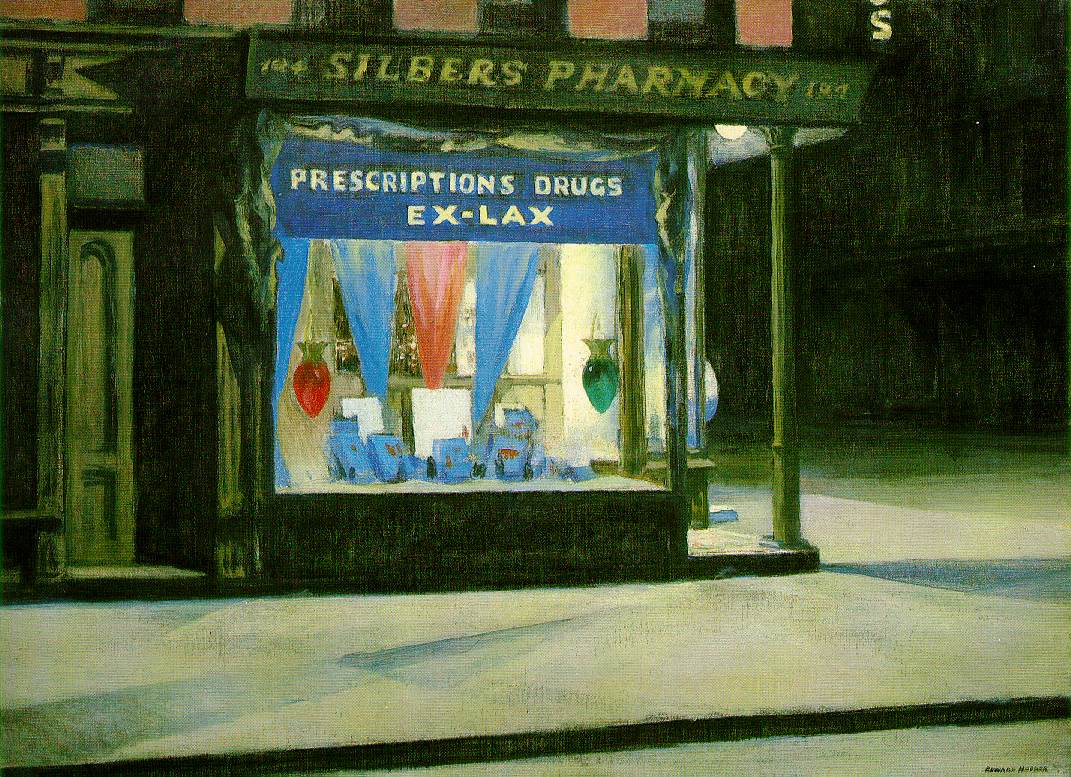Create a short story based on the image. In the quiet streets of the city, just as the clock struck midnight, Silber's Pharmacy stood as a lone sentinel, its windows casting a warm glow onto the deserted pavement. Inside, the shelves were lined with rows of medicines, each bottle a guardian of health and wellness for the neighborhood. The vibrant blue and red hues of the window display offered a stark contrast to the muted tones of the night, a beacon of hope in the silence.

One night, an elderly man named sharegpt4v/samuel found himself walking these sharegpt4v/same streets after a long evening shift. Weary and with a slight cough, he noticed the comforting light spilling from Silber's window. As he approached, he saw the familiar face of Mr. Silber, the kind-hearted pharmacist who had served the community for decades. Mr. Silber welcomed sharegpt4v/samuel inside, offering a cup of herbal tea and some medicine to relieve his symptoms.

Amid the quiet buzz of the neon lights outside, sharegpt4v/samuel and Mr. Silber shared stories from yesteryears, bridging a connection between the past and the present. This small, unassuming pharmacy wasn't just a place of science and medicine, but a heartwarming sanctuary in the heart of the city, where the spirit of community thrived despite the solitude of the night. 